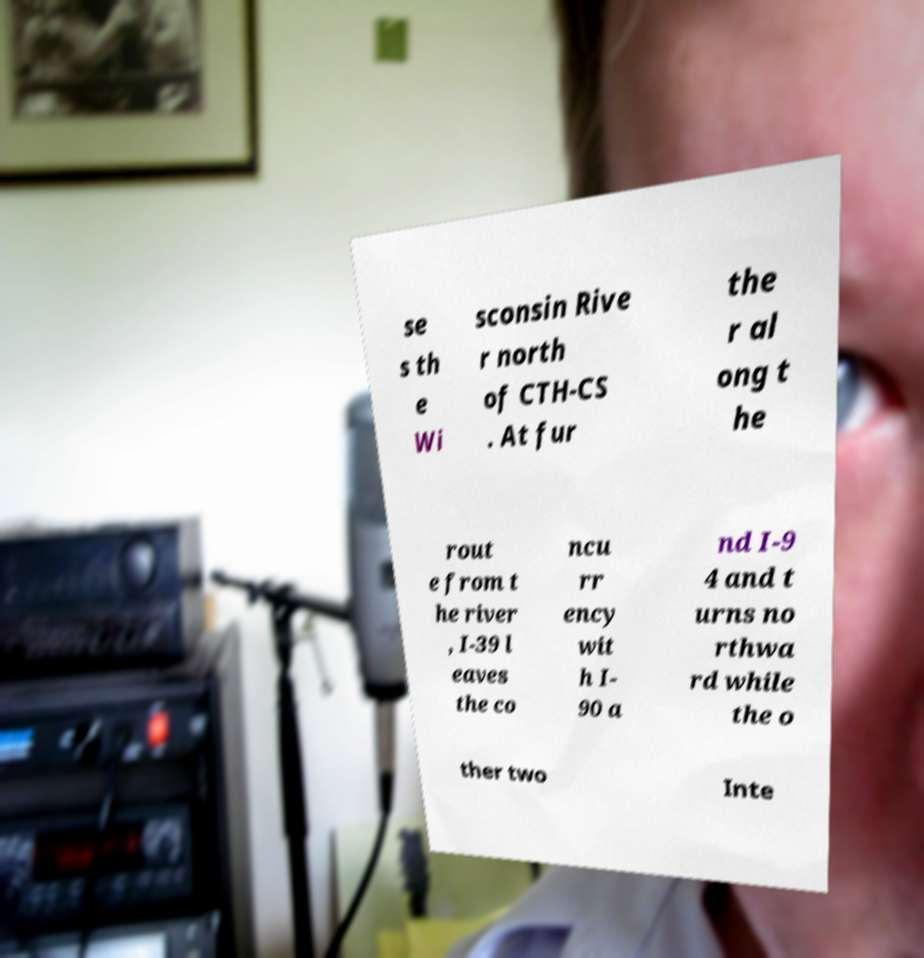Please read and relay the text visible in this image. What does it say? se s th e Wi sconsin Rive r north of CTH-CS . At fur the r al ong t he rout e from t he river , I-39 l eaves the co ncu rr ency wit h I- 90 a nd I-9 4 and t urns no rthwa rd while the o ther two Inte 